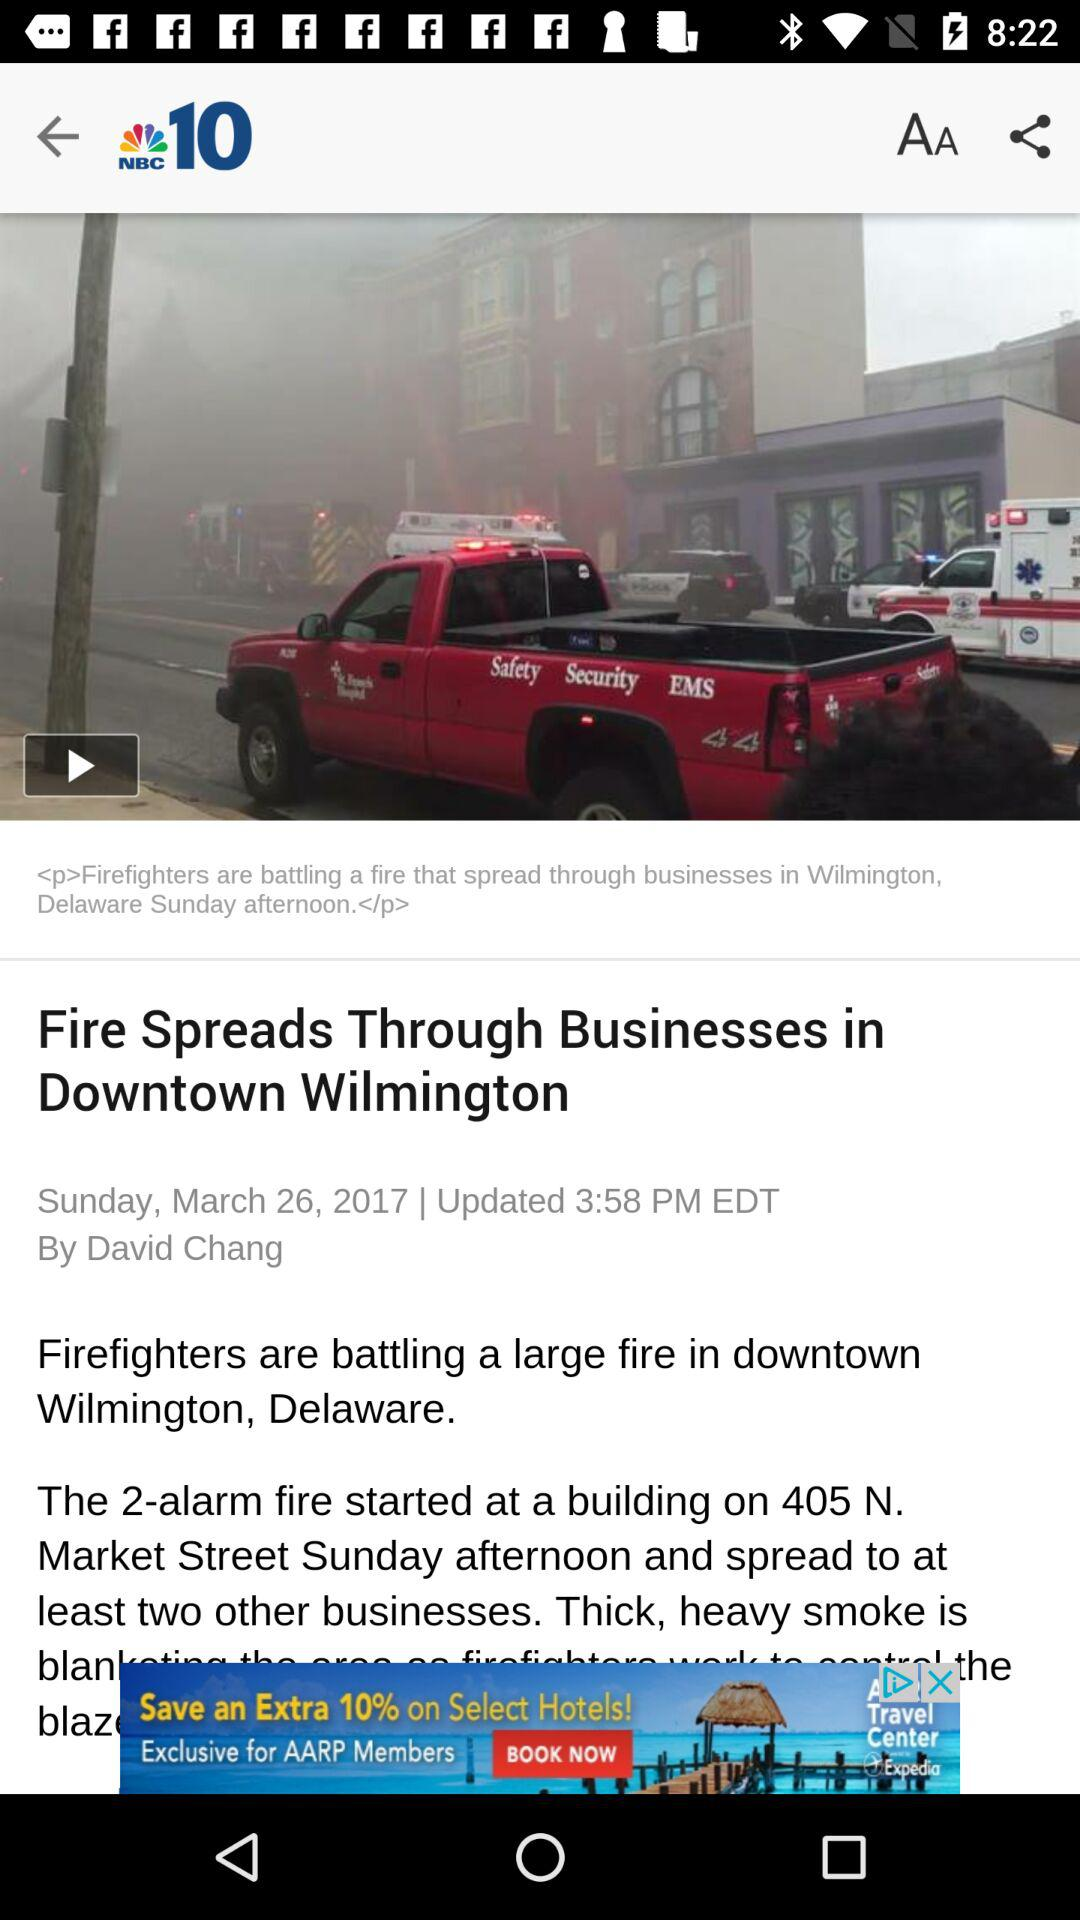What is the day on 26 March 2017? The day is Sunday. 